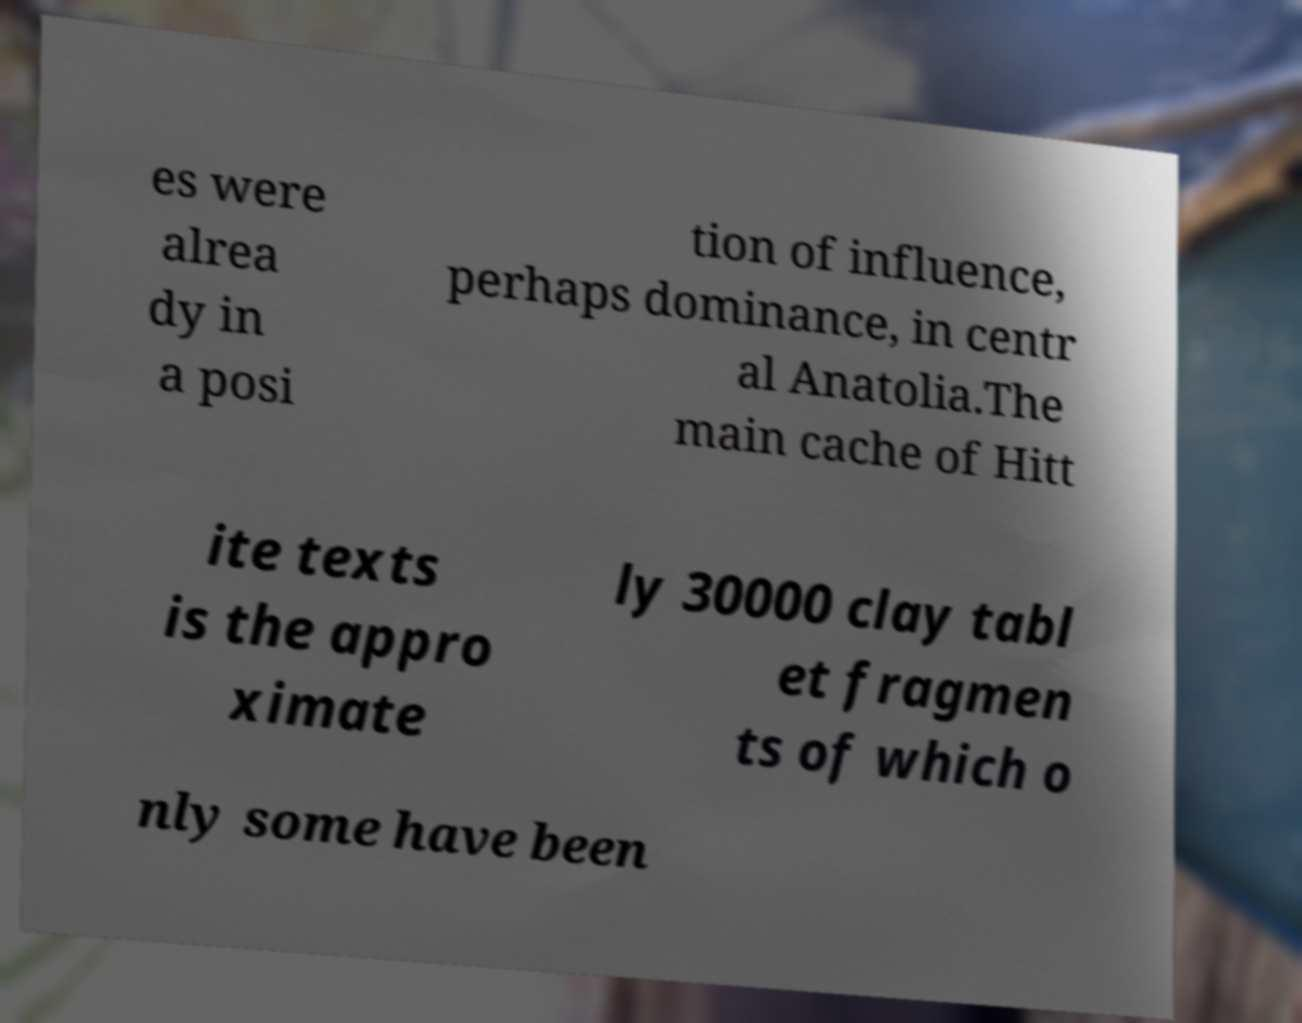Please identify and transcribe the text found in this image. es were alrea dy in a posi tion of influence, perhaps dominance, in centr al Anatolia.The main cache of Hitt ite texts is the appro ximate ly 30000 clay tabl et fragmen ts of which o nly some have been 